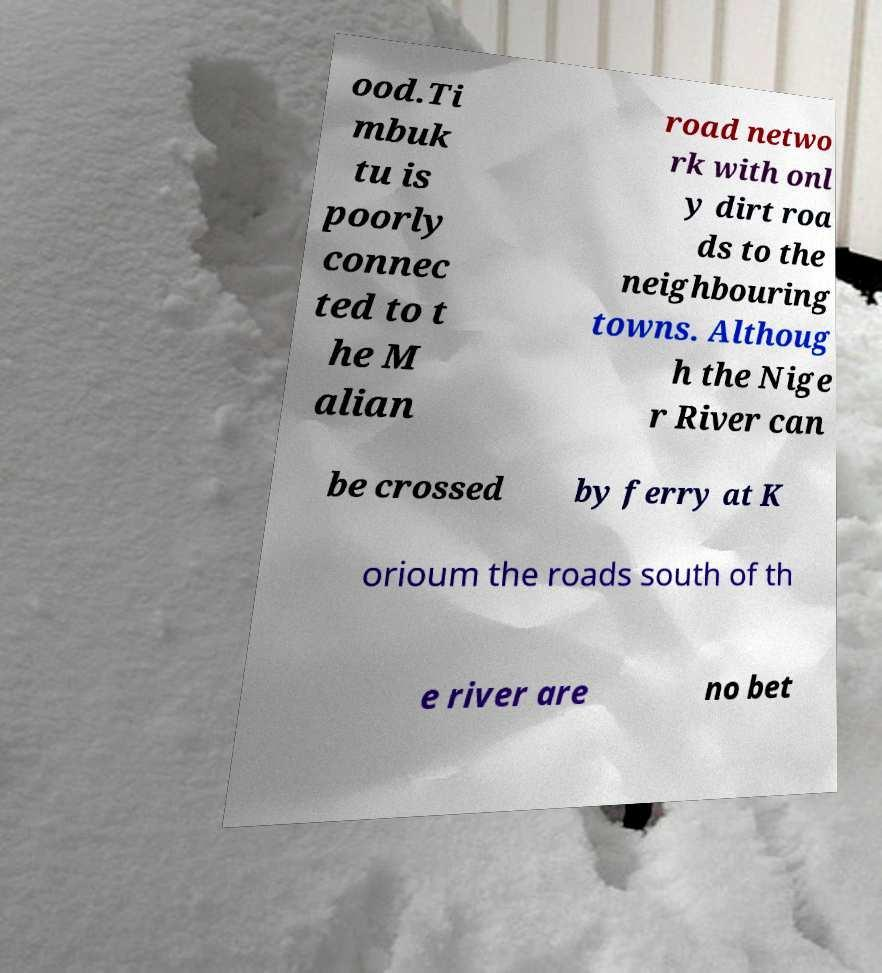Please identify and transcribe the text found in this image. ood.Ti mbuk tu is poorly connec ted to t he M alian road netwo rk with onl y dirt roa ds to the neighbouring towns. Althoug h the Nige r River can be crossed by ferry at K orioum the roads south of th e river are no bet 